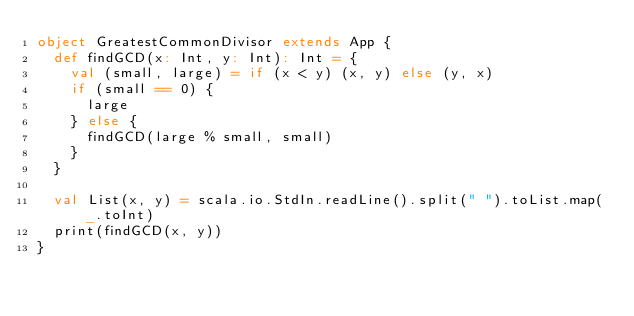<code> <loc_0><loc_0><loc_500><loc_500><_Scala_>object GreatestCommonDivisor extends App {
  def findGCD(x: Int, y: Int): Int = {
    val (small, large) = if (x < y) (x, y) else (y, x)
    if (small == 0) {
      large
    } else {
      findGCD(large % small, small)
    }
  }

  val List(x, y) = scala.io.StdIn.readLine().split(" ").toList.map(_.toInt)
  print(findGCD(x, y))
}</code> 